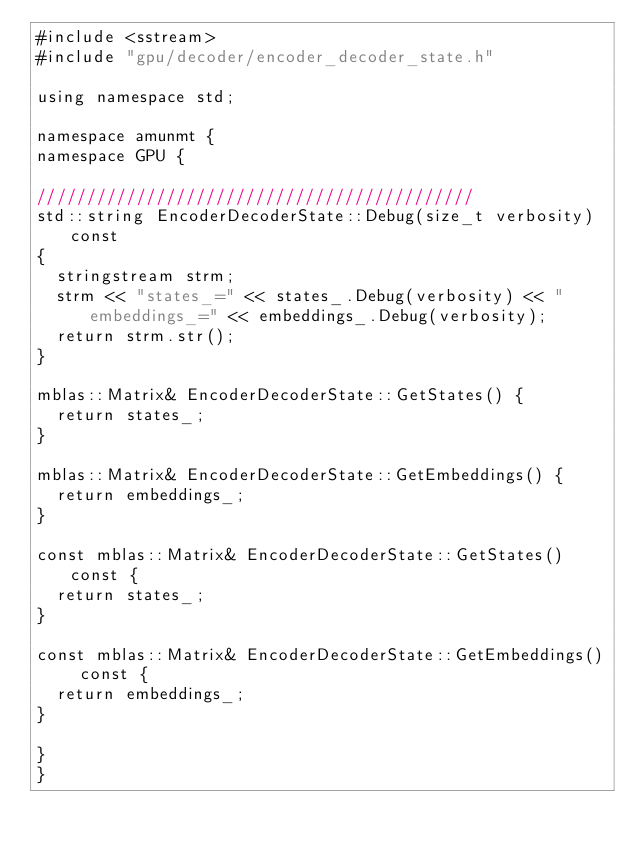Convert code to text. <code><loc_0><loc_0><loc_500><loc_500><_Cuda_>#include <sstream>
#include "gpu/decoder/encoder_decoder_state.h"

using namespace std;

namespace amunmt {
namespace GPU {

////////////////////////////////////////////
std::string EncoderDecoderState::Debug(size_t verbosity) const
{
  stringstream strm;
  strm << "states_=" << states_.Debug(verbosity) << " embeddings_=" << embeddings_.Debug(verbosity);
  return strm.str();
}

mblas::Matrix& EncoderDecoderState::GetStates() {
  return states_;
}

mblas::Matrix& EncoderDecoderState::GetEmbeddings() {
  return embeddings_;
}

const mblas::Matrix& EncoderDecoderState::GetStates() const {
  return states_;
}

const mblas::Matrix& EncoderDecoderState::GetEmbeddings() const {
  return embeddings_;
}

}
}

</code> 